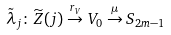<formula> <loc_0><loc_0><loc_500><loc_500>\tilde { \lambda } _ { j } \colon \widetilde { Z } ( j ) \overset { r _ { V } } \to V _ { 0 } \overset { \mu } \to S _ { 2 m - 1 }</formula> 